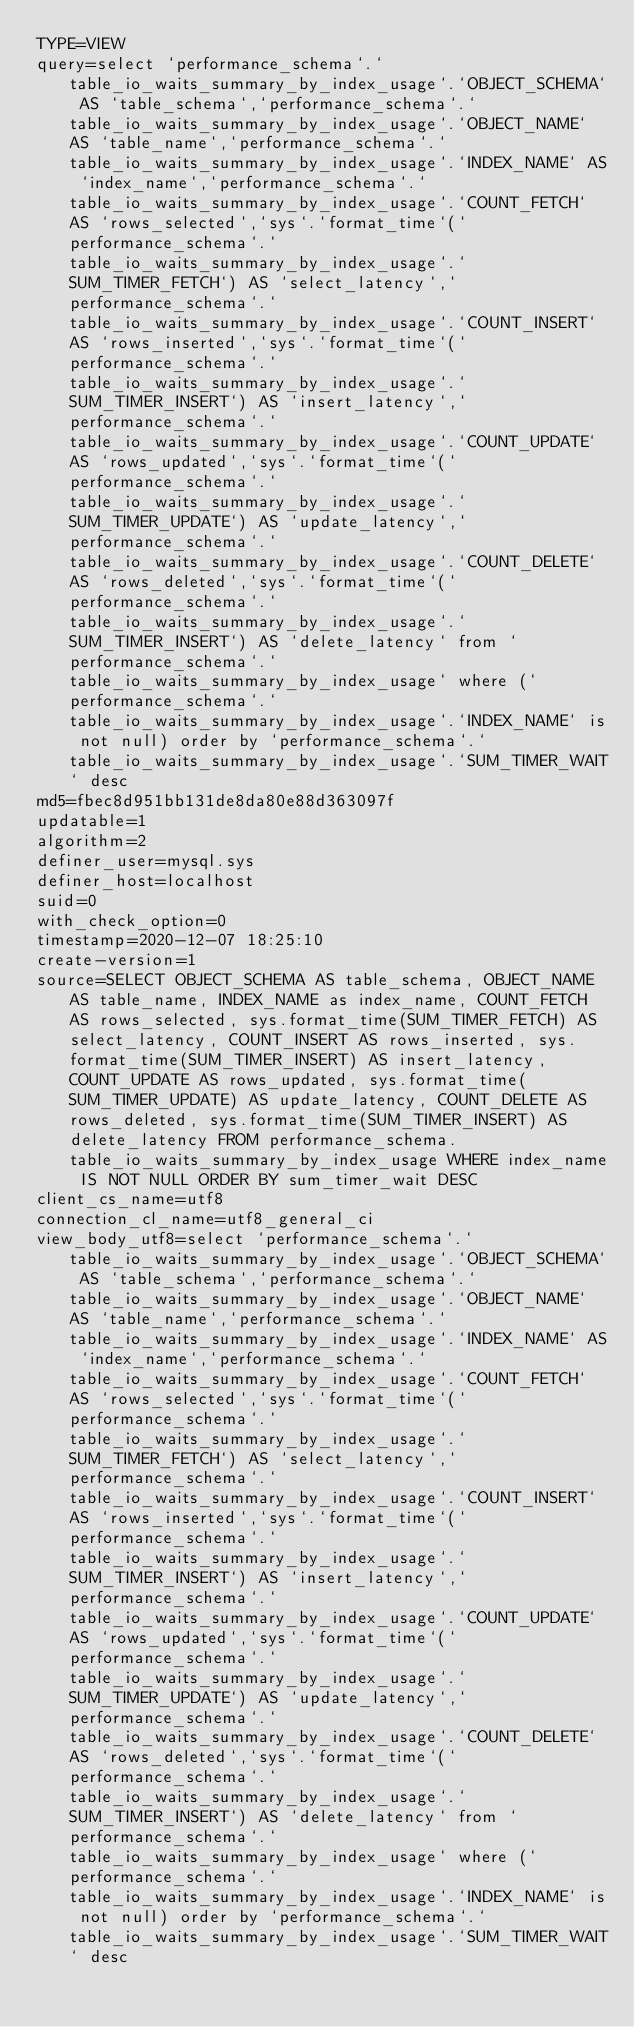Convert code to text. <code><loc_0><loc_0><loc_500><loc_500><_VisualBasic_>TYPE=VIEW
query=select `performance_schema`.`table_io_waits_summary_by_index_usage`.`OBJECT_SCHEMA` AS `table_schema`,`performance_schema`.`table_io_waits_summary_by_index_usage`.`OBJECT_NAME` AS `table_name`,`performance_schema`.`table_io_waits_summary_by_index_usage`.`INDEX_NAME` AS `index_name`,`performance_schema`.`table_io_waits_summary_by_index_usage`.`COUNT_FETCH` AS `rows_selected`,`sys`.`format_time`(`performance_schema`.`table_io_waits_summary_by_index_usage`.`SUM_TIMER_FETCH`) AS `select_latency`,`performance_schema`.`table_io_waits_summary_by_index_usage`.`COUNT_INSERT` AS `rows_inserted`,`sys`.`format_time`(`performance_schema`.`table_io_waits_summary_by_index_usage`.`SUM_TIMER_INSERT`) AS `insert_latency`,`performance_schema`.`table_io_waits_summary_by_index_usage`.`COUNT_UPDATE` AS `rows_updated`,`sys`.`format_time`(`performance_schema`.`table_io_waits_summary_by_index_usage`.`SUM_TIMER_UPDATE`) AS `update_latency`,`performance_schema`.`table_io_waits_summary_by_index_usage`.`COUNT_DELETE` AS `rows_deleted`,`sys`.`format_time`(`performance_schema`.`table_io_waits_summary_by_index_usage`.`SUM_TIMER_INSERT`) AS `delete_latency` from `performance_schema`.`table_io_waits_summary_by_index_usage` where (`performance_schema`.`table_io_waits_summary_by_index_usage`.`INDEX_NAME` is not null) order by `performance_schema`.`table_io_waits_summary_by_index_usage`.`SUM_TIMER_WAIT` desc
md5=fbec8d951bb131de8da80e88d363097f
updatable=1
algorithm=2
definer_user=mysql.sys
definer_host=localhost
suid=0
with_check_option=0
timestamp=2020-12-07 18:25:10
create-version=1
source=SELECT OBJECT_SCHEMA AS table_schema, OBJECT_NAME AS table_name, INDEX_NAME as index_name, COUNT_FETCH AS rows_selected, sys.format_time(SUM_TIMER_FETCH) AS select_latency, COUNT_INSERT AS rows_inserted, sys.format_time(SUM_TIMER_INSERT) AS insert_latency, COUNT_UPDATE AS rows_updated, sys.format_time(SUM_TIMER_UPDATE) AS update_latency, COUNT_DELETE AS rows_deleted, sys.format_time(SUM_TIMER_INSERT) AS delete_latency FROM performance_schema.table_io_waits_summary_by_index_usage WHERE index_name IS NOT NULL ORDER BY sum_timer_wait DESC
client_cs_name=utf8
connection_cl_name=utf8_general_ci
view_body_utf8=select `performance_schema`.`table_io_waits_summary_by_index_usage`.`OBJECT_SCHEMA` AS `table_schema`,`performance_schema`.`table_io_waits_summary_by_index_usage`.`OBJECT_NAME` AS `table_name`,`performance_schema`.`table_io_waits_summary_by_index_usage`.`INDEX_NAME` AS `index_name`,`performance_schema`.`table_io_waits_summary_by_index_usage`.`COUNT_FETCH` AS `rows_selected`,`sys`.`format_time`(`performance_schema`.`table_io_waits_summary_by_index_usage`.`SUM_TIMER_FETCH`) AS `select_latency`,`performance_schema`.`table_io_waits_summary_by_index_usage`.`COUNT_INSERT` AS `rows_inserted`,`sys`.`format_time`(`performance_schema`.`table_io_waits_summary_by_index_usage`.`SUM_TIMER_INSERT`) AS `insert_latency`,`performance_schema`.`table_io_waits_summary_by_index_usage`.`COUNT_UPDATE` AS `rows_updated`,`sys`.`format_time`(`performance_schema`.`table_io_waits_summary_by_index_usage`.`SUM_TIMER_UPDATE`) AS `update_latency`,`performance_schema`.`table_io_waits_summary_by_index_usage`.`COUNT_DELETE` AS `rows_deleted`,`sys`.`format_time`(`performance_schema`.`table_io_waits_summary_by_index_usage`.`SUM_TIMER_INSERT`) AS `delete_latency` from `performance_schema`.`table_io_waits_summary_by_index_usage` where (`performance_schema`.`table_io_waits_summary_by_index_usage`.`INDEX_NAME` is not null) order by `performance_schema`.`table_io_waits_summary_by_index_usage`.`SUM_TIMER_WAIT` desc
</code> 